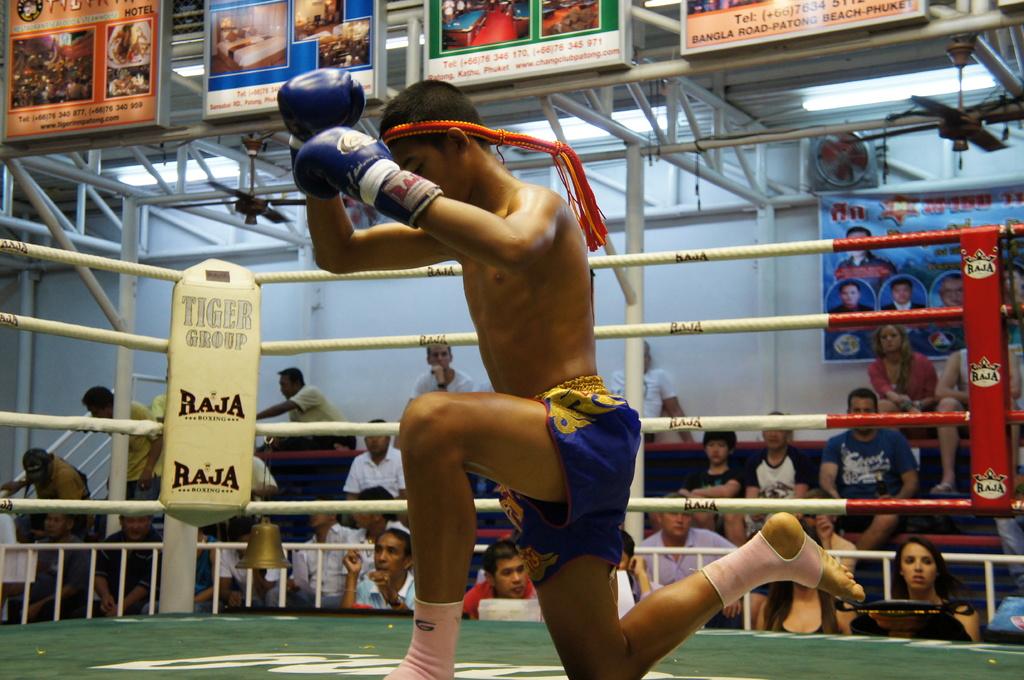What words is displayed at the top of the turnbuckle?
Your answer should be very brief. Tiger group. 